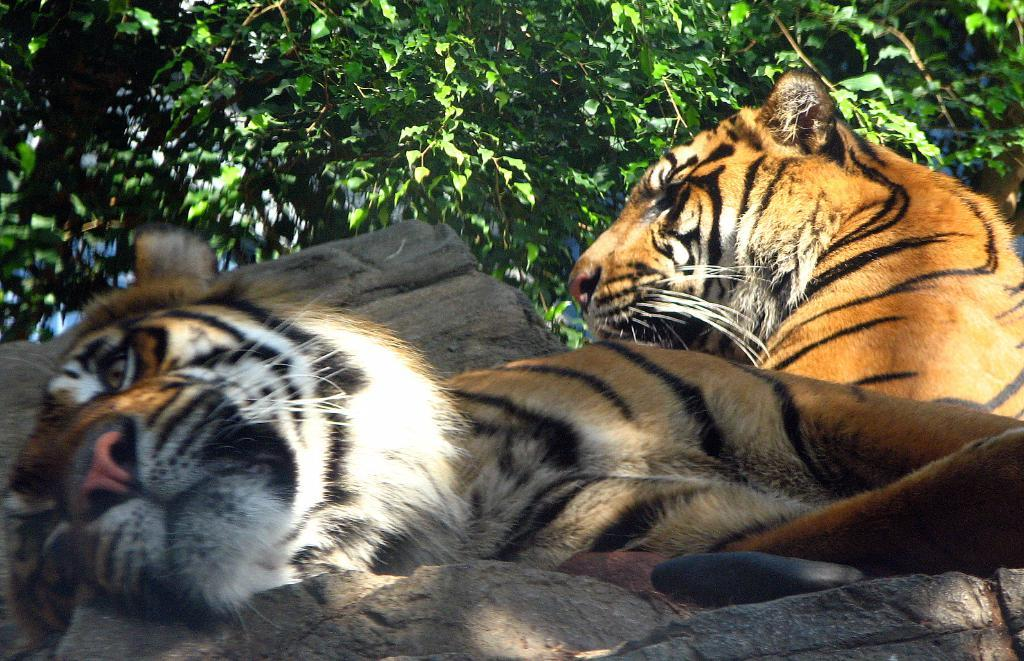What animals are present in the image? There are tigers in the image. What can be seen in the background of the image? There are trees in the background of the image. What is the distribution of sand in the image? There is no sand present in the image; it features tigers and trees. 